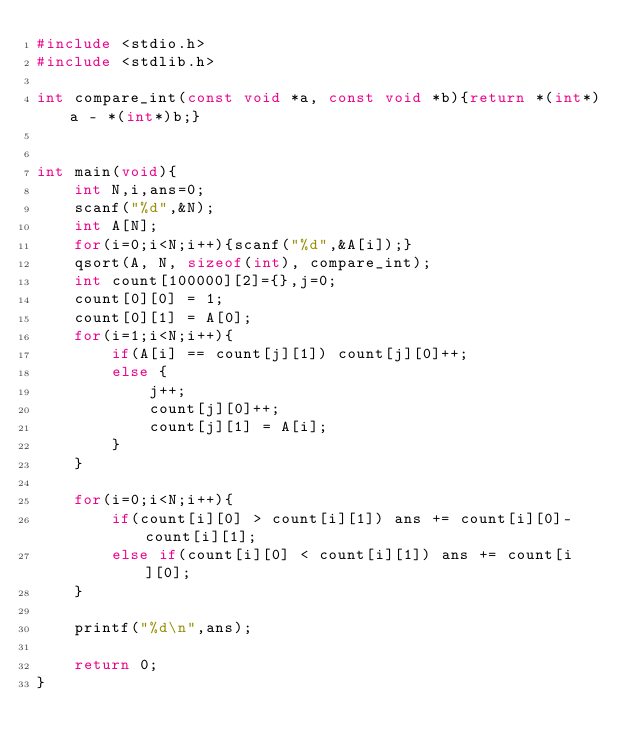<code> <loc_0><loc_0><loc_500><loc_500><_C_>#include <stdio.h>
#include <stdlib.h>

int compare_int(const void *a, const void *b){return *(int*)a - *(int*)b;}


int main(void){
	int N,i,ans=0;
	scanf("%d",&N);
	int A[N];
	for(i=0;i<N;i++){scanf("%d",&A[i]);}
	qsort(A, N, sizeof(int), compare_int);
	int count[100000][2]={},j=0;
	count[0][0] = 1;
	count[0][1] = A[0];
	for(i=1;i<N;i++){
		if(A[i] == count[j][1]) count[j][0]++;
		else {
			j++;
			count[j][0]++;
			count[j][1] = A[i];
		}
	}
	
	for(i=0;i<N;i++){
		if(count[i][0] > count[i][1]) ans += count[i][0]-count[i][1];
		else if(count[i][0] < count[i][1]) ans += count[i][0];
	}
	
	printf("%d\n",ans);
	
	return 0;
}</code> 